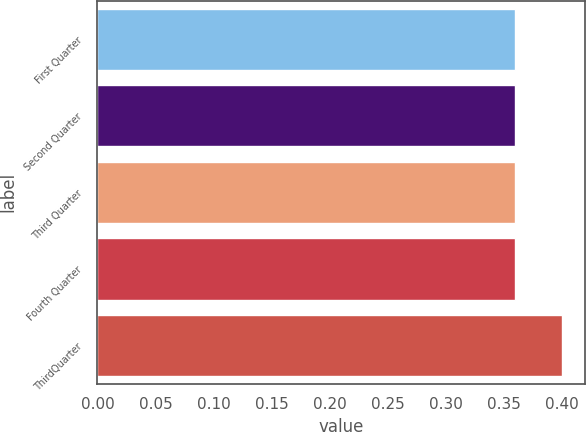Convert chart to OTSL. <chart><loc_0><loc_0><loc_500><loc_500><bar_chart><fcel>First Quarter<fcel>Second Quarter<fcel>Third Quarter<fcel>Fourth Quarter<fcel>ThirdQuarter<nl><fcel>0.36<fcel>0.36<fcel>0.36<fcel>0.36<fcel>0.4<nl></chart> 